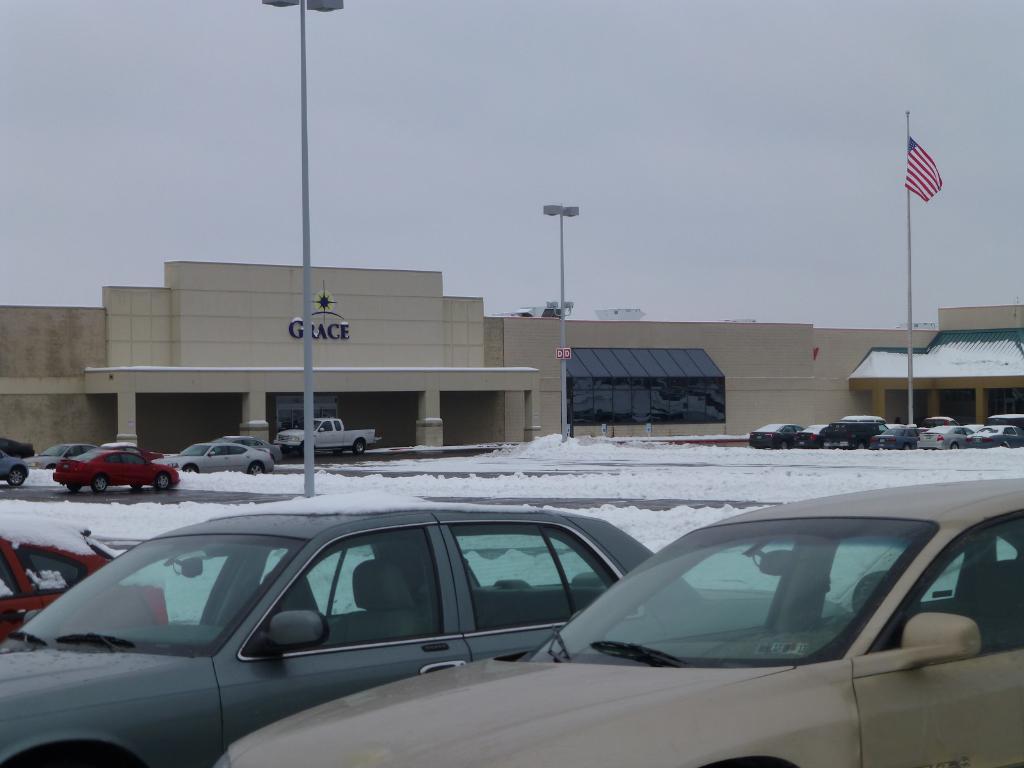How would you summarize this image in a sentence or two? In this picture there is a building and there is a text on the building. There are vehicles and there are poles, on the poles there are lights and there is a flag. At the top there is sky. At the bottom there is a road and there is snow. 